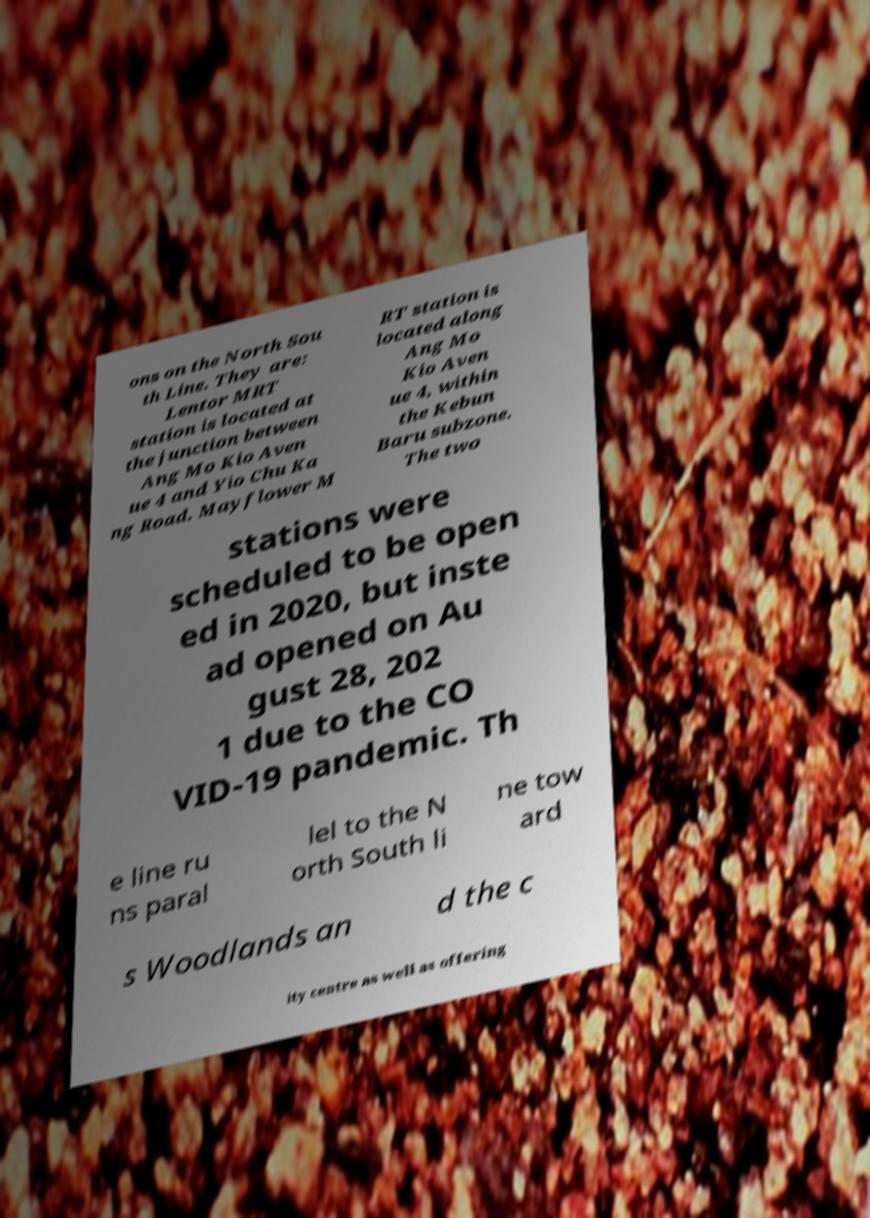Could you assist in decoding the text presented in this image and type it out clearly? ons on the North Sou th Line. They are: Lentor MRT station is located at the junction between Ang Mo Kio Aven ue 4 and Yio Chu Ka ng Road. Mayflower M RT station is located along Ang Mo Kio Aven ue 4, within the Kebun Baru subzone. The two stations were scheduled to be open ed in 2020, but inste ad opened on Au gust 28, 202 1 due to the CO VID-19 pandemic. Th e line ru ns paral lel to the N orth South li ne tow ard s Woodlands an d the c ity centre as well as offering 